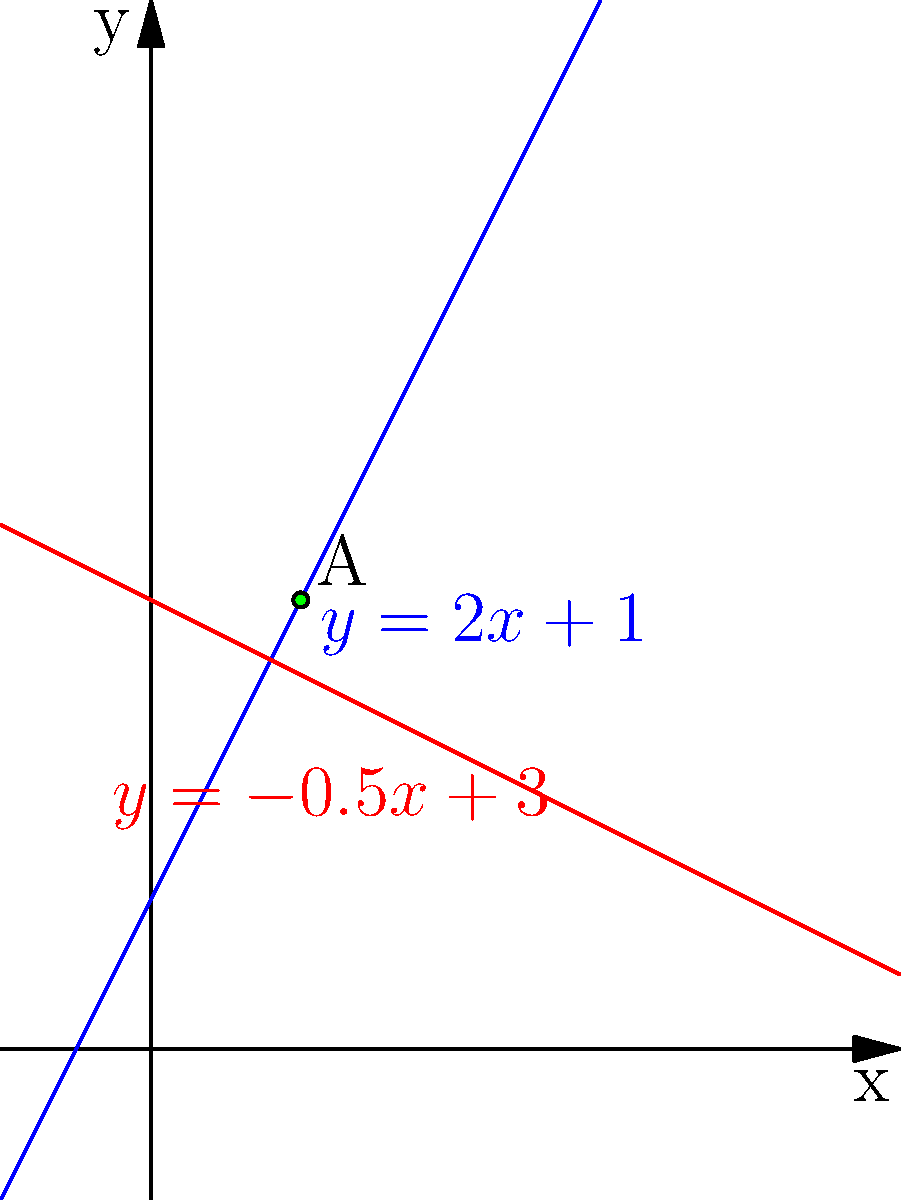In the graph above, two linear equations are plotted: $y = 2x + 1$ (blue) and $y = -0.5x + 3$ (red). Point A represents their intersection. How would you interpret the slopes of these lines in the context of policy impact over time, and at what point (x-coordinate) do the policies represented by these lines have equal impact? To answer this question, let's break it down step-by-step:

1. Interpreting the slopes:
   a) Blue line ($y = 2x + 1$): The slope is 2, which is positive and steep. In a policy context, this could represent a rapidly increasing impact over time.
   b) Red line ($y = -0.5x + 3$): The slope is -0.5, which is negative and less steep. This could represent a gradually decreasing impact over time.

2. Finding the intersection point:
   To find where the policies have equal impact, we need to solve the equation:
   $2x + 1 = -0.5x + 3$

3. Solving for x:
   $2x + 1 = -0.5x + 3$
   $2.5x = 2$
   $x = \frac{2}{2.5} = 0.8$

4. Verifying the y-coordinate:
   $y = 2(0.8) + 1 = 2.6$
   Or: $y = -0.5(0.8) + 3 = 2.6$

Therefore, the policies have equal impact at $x = 0.8$, which corresponds to the x-coordinate of point A.

5. Interpretation:
   The intersection point (0.8, 2.6) represents the time (x) and level of impact (y) where both policies have the same effect. Before this point, the policy represented by the red line has a higher impact, while after this point, the blue line's policy becomes more impactful.
Answer: Slopes represent rate of policy impact change; policies have equal impact at x = 0.8. 